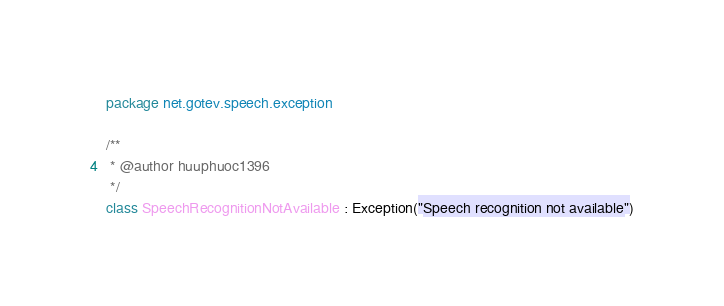Convert code to text. <code><loc_0><loc_0><loc_500><loc_500><_Kotlin_>package net.gotev.speech.exception

/**
 * @author huuphuoc1396
 */
class SpeechRecognitionNotAvailable : Exception("Speech recognition not available")
</code> 